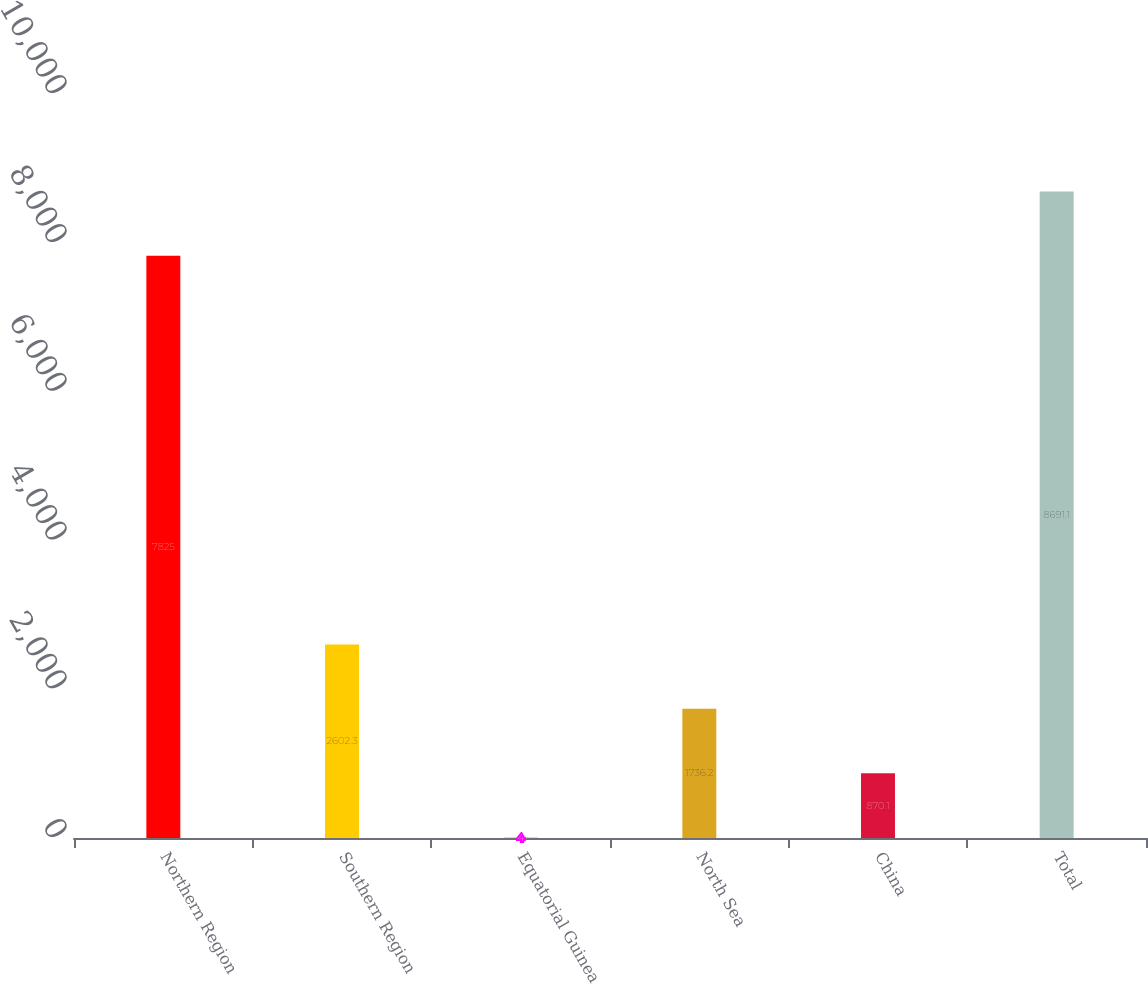Convert chart. <chart><loc_0><loc_0><loc_500><loc_500><bar_chart><fcel>Northern Region<fcel>Southern Region<fcel>Equatorial Guinea<fcel>North Sea<fcel>China<fcel>Total<nl><fcel>7825<fcel>2602.3<fcel>4<fcel>1736.2<fcel>870.1<fcel>8691.1<nl></chart> 